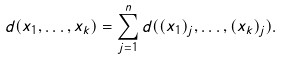Convert formula to latex. <formula><loc_0><loc_0><loc_500><loc_500>d ( x _ { 1 } , \dots , x _ { k } ) = \sum _ { j = 1 } ^ { n } d ( ( x _ { 1 } ) _ { j } , \dots , ( x _ { k } ) _ { j } ) .</formula> 